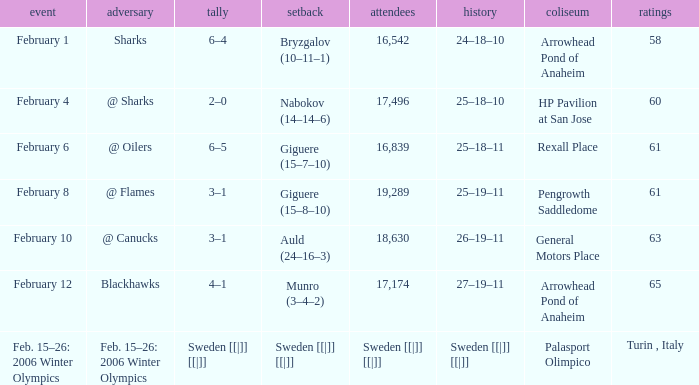What is the record when the score was 2–0? 25–18–10. 